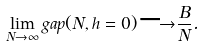Convert formula to latex. <formula><loc_0><loc_0><loc_500><loc_500>\lim _ { N \rightarrow \infty } g a p ( N , h = 0 ) { \longrightarrow } \frac { B } { N } .</formula> 